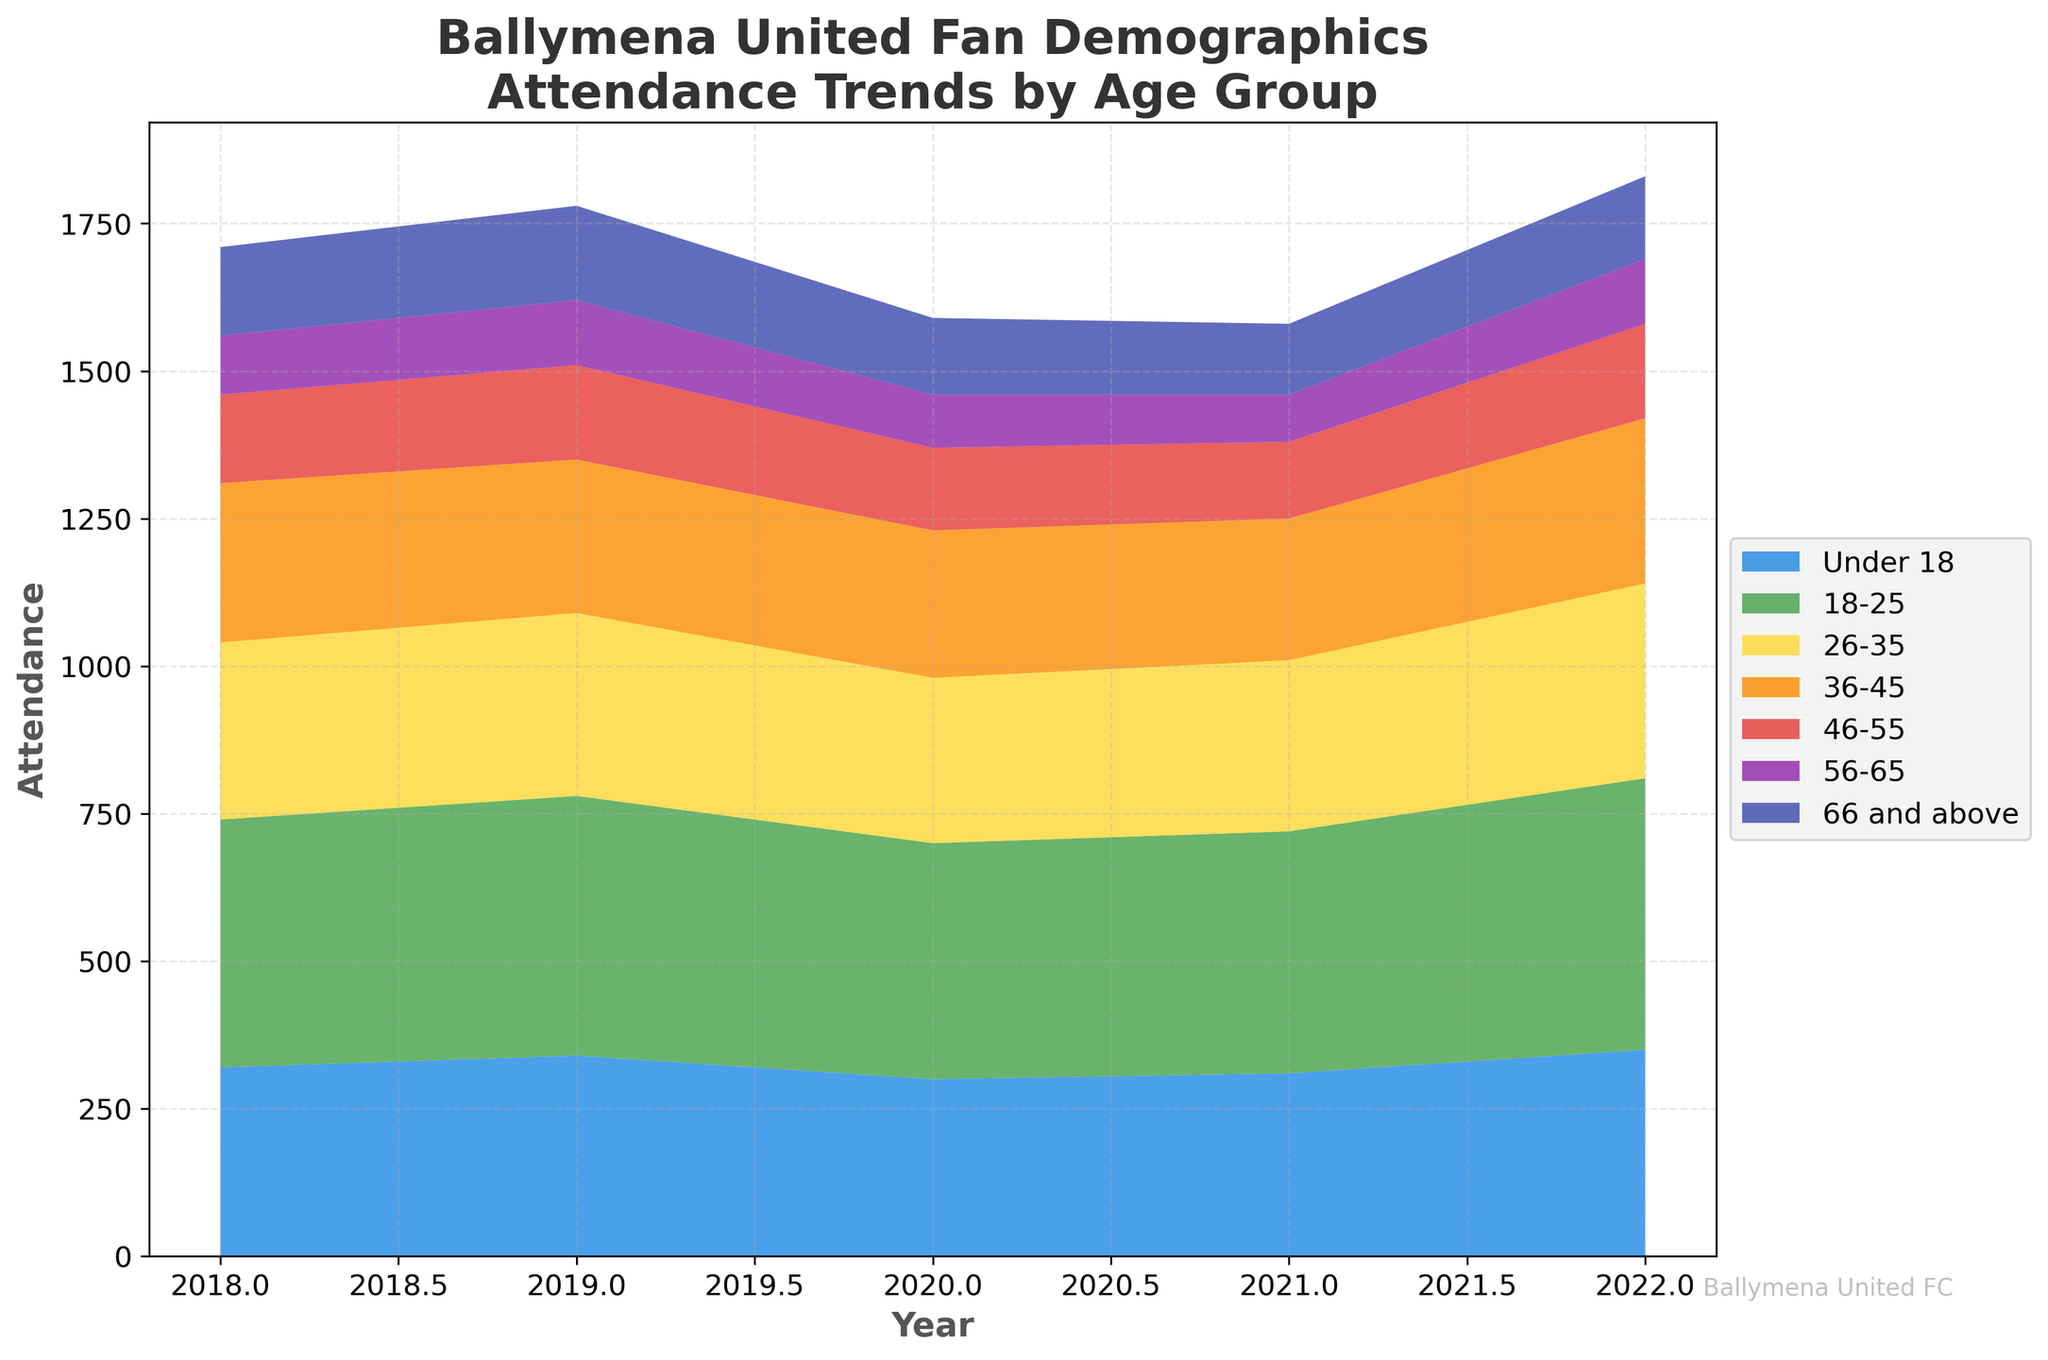What is the title of the figure? The title of the figure is prominently displayed at the top. It reads, "Ballymena United Fan Demographics Attendance Trends by Age Group."
Answer: Ballymena United Fan Demographics Attendance Trends by Age Group How many age groups are represented in the data? The legend on the right side of the figure lists the different age groups. Counting them reveals there are seven age groups.
Answer: Seven Which age group had the highest attendance in 2018? By looking at the stack heights for each age group in 2018, we see that the 26-35 age group has the highest stacked portion.
Answer: 26-35 Which age group saw the greatest increase in attendance from 2021 to 2022? Comparing the stack heights from 2021 to 2022, the age group 18-25 had a significant increase, evident through the noticeable rise in the area covered from 2021 to 2022.
Answer: 18-25 How did attendance for the "Under 18" age group change over the years? Observing the stack portion labeled "Under 18," we see a modest fluctuation with slight decreases from 2018 to 2021 followed by an increase in 2022.
Answer: Decreased then increased Which age group had the lowest attendance in 2020? The smallest stack for 2020 is visibly associated with the "66 and above" age group.
Answer: 66 and above Compare the attendance trends of the 26-35 and 36-45 age groups. Which group maintained consistently higher attendance? By examining the areas occupied by both age groups over the years, the 26-35 group consistently has larger portions compared to the 36-45 group.
Answer: 26-35 What is the trend of the total attendance from 2018 to 2022? Summing up all age group stacks visually for each year, it is clear that the total attendance decreased from 2018 to 2021 and then increased in 2022.
Answer: Decreased then increased 